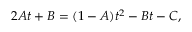<formula> <loc_0><loc_0><loc_500><loc_500>2 A t + B = ( 1 - A ) t ^ { 2 } - B t - C ,</formula> 